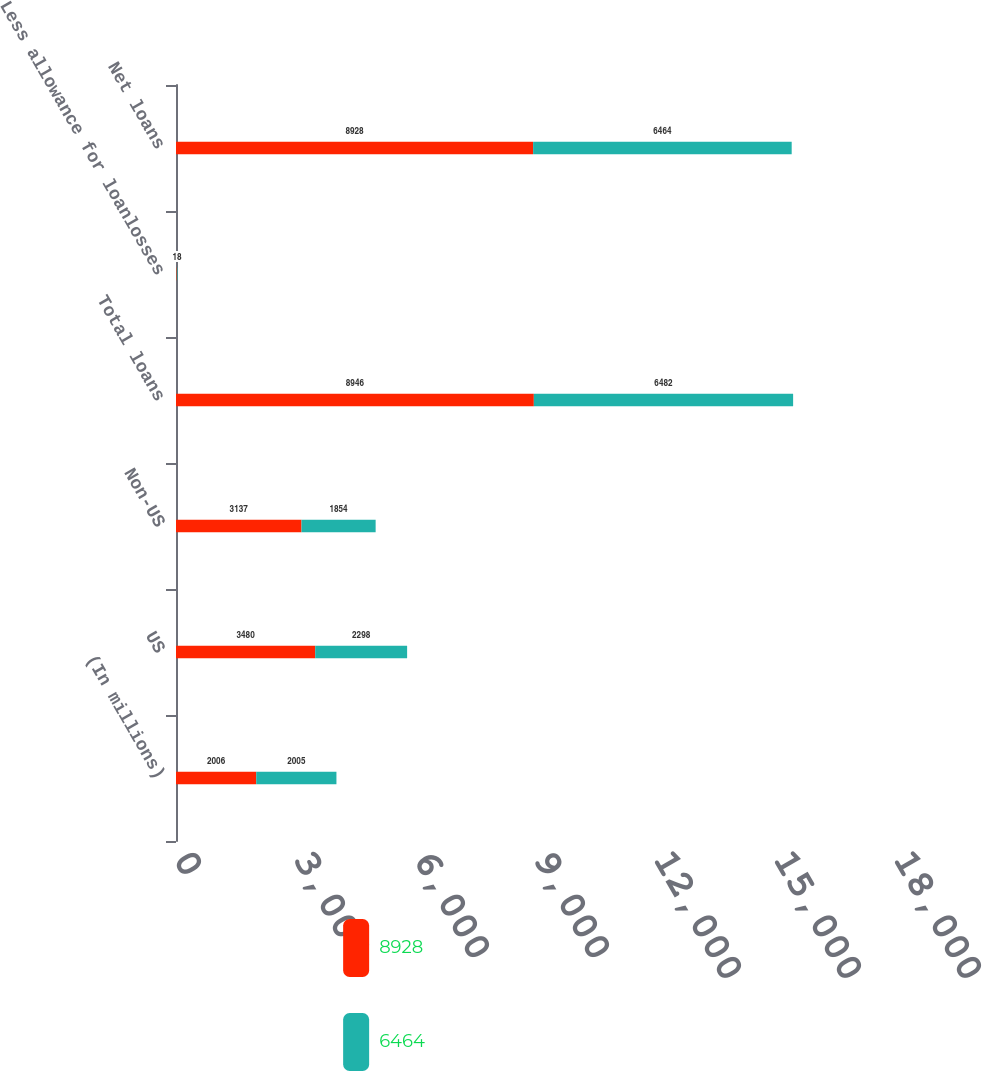<chart> <loc_0><loc_0><loc_500><loc_500><stacked_bar_chart><ecel><fcel>(In millions)<fcel>US<fcel>Non-US<fcel>Total loans<fcel>Less allowance for loanlosses<fcel>Net loans<nl><fcel>8928<fcel>2006<fcel>3480<fcel>3137<fcel>8946<fcel>18<fcel>8928<nl><fcel>6464<fcel>2005<fcel>2298<fcel>1854<fcel>6482<fcel>18<fcel>6464<nl></chart> 